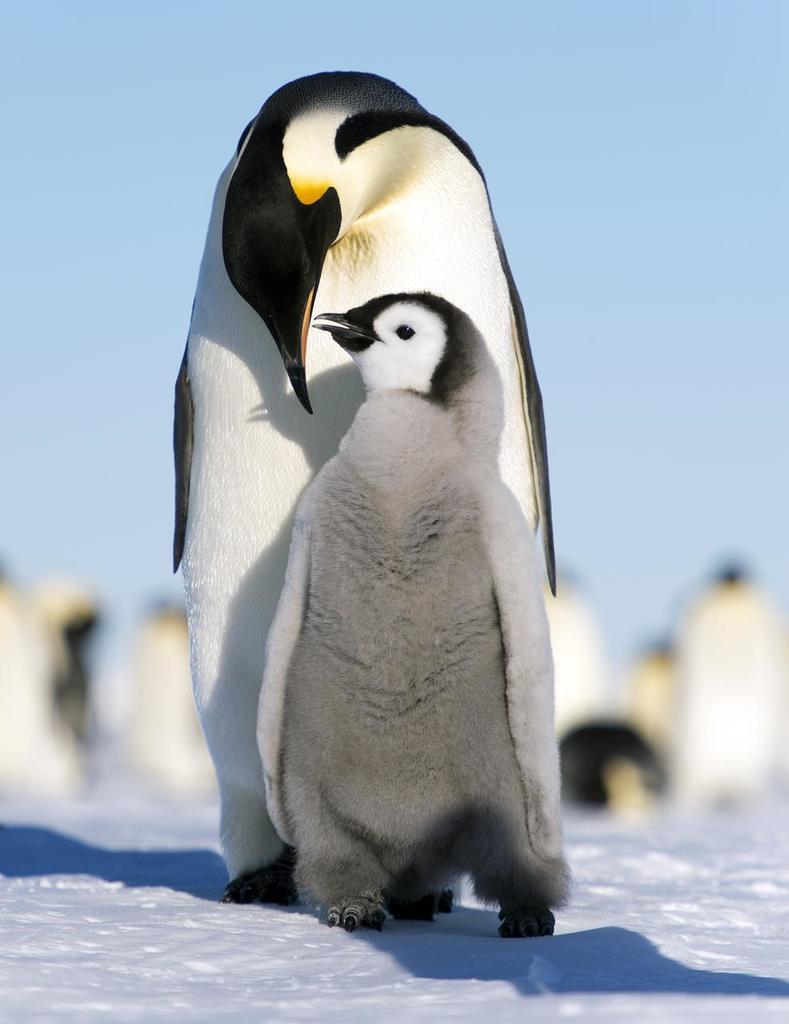Please provide a concise description of this image. In this image we can see there is a snow and penguins. In the background there is a sky. 